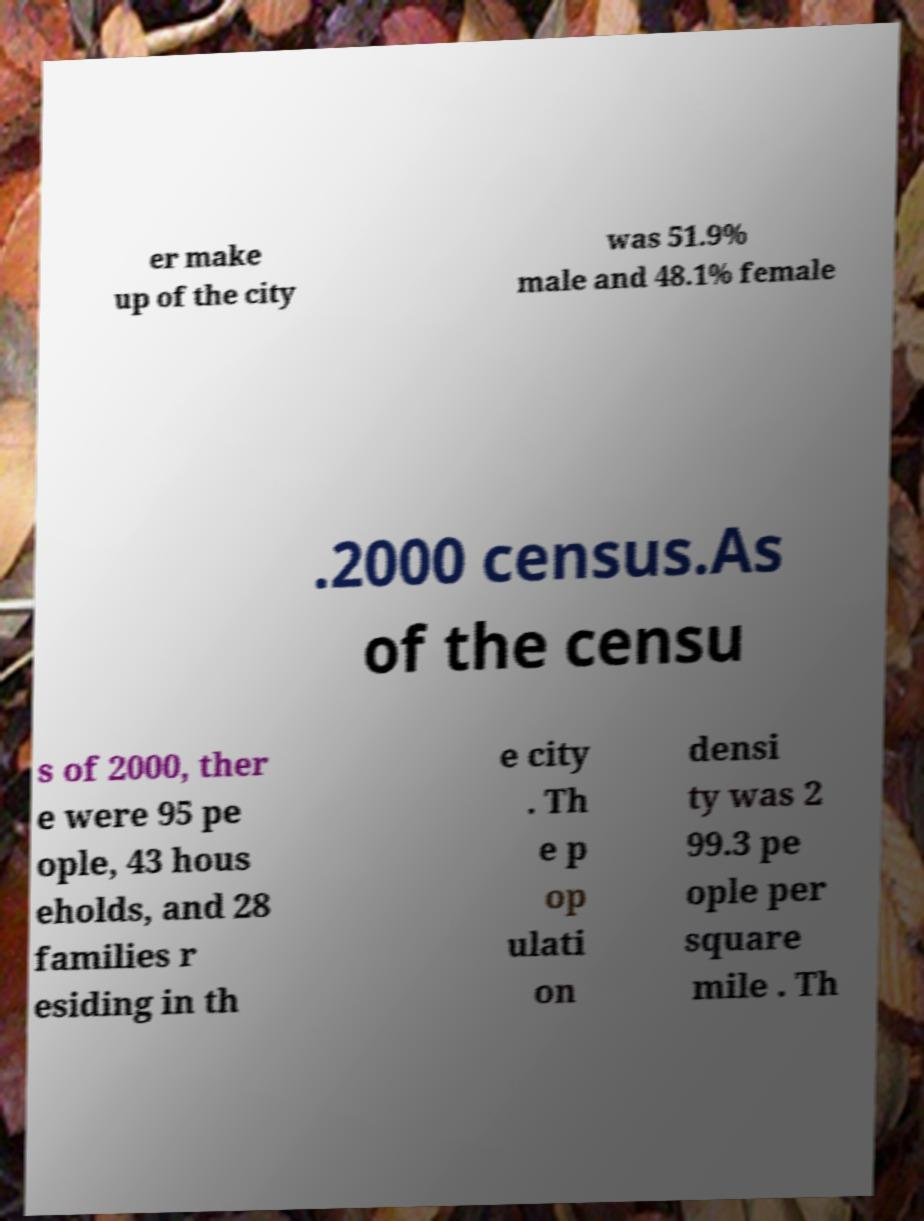Can you accurately transcribe the text from the provided image for me? er make up of the city was 51.9% male and 48.1% female .2000 census.As of the censu s of 2000, ther e were 95 pe ople, 43 hous eholds, and 28 families r esiding in th e city . Th e p op ulati on densi ty was 2 99.3 pe ople per square mile . Th 